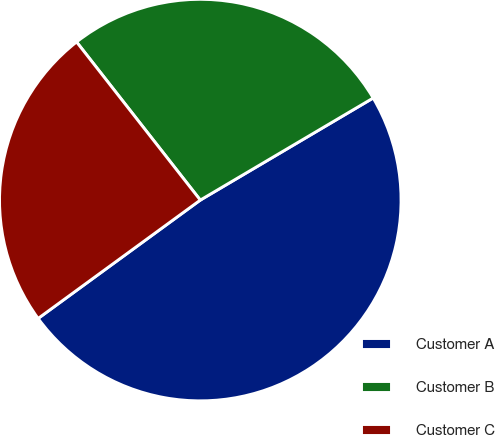Convert chart. <chart><loc_0><loc_0><loc_500><loc_500><pie_chart><fcel>Customer A<fcel>Customer B<fcel>Customer C<nl><fcel>48.46%<fcel>27.08%<fcel>24.47%<nl></chart> 